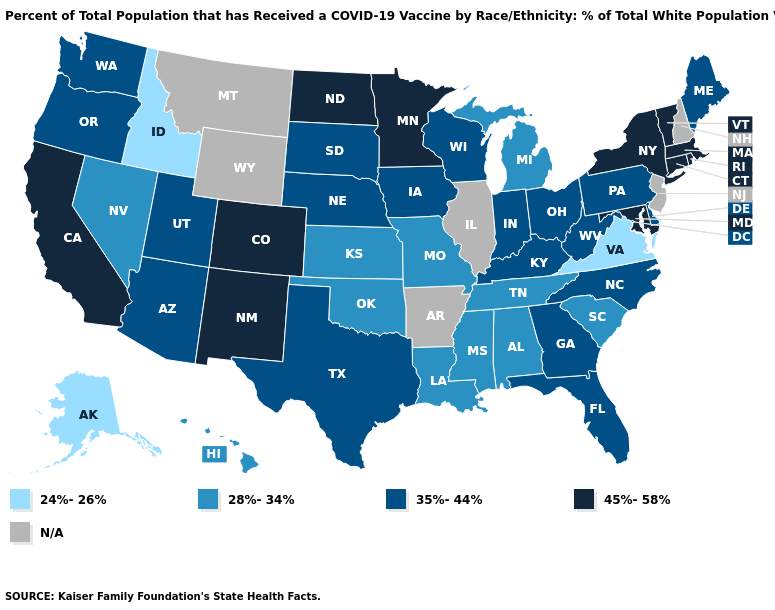What is the lowest value in the USA?
Short answer required. 24%-26%. What is the value of New Hampshire?
Be succinct. N/A. Does Alaska have the lowest value in the USA?
Keep it brief. Yes. What is the value of Hawaii?
Answer briefly. 28%-34%. What is the lowest value in the Northeast?
Write a very short answer. 35%-44%. Which states have the lowest value in the USA?
Keep it brief. Alaska, Idaho, Virginia. What is the highest value in the USA?
Give a very brief answer. 45%-58%. What is the value of Oklahoma?
Answer briefly. 28%-34%. Name the states that have a value in the range 24%-26%?
Short answer required. Alaska, Idaho, Virginia. Which states have the lowest value in the USA?
Write a very short answer. Alaska, Idaho, Virginia. What is the highest value in the West ?
Short answer required. 45%-58%. What is the value of Georgia?
Answer briefly. 35%-44%. Which states have the lowest value in the USA?
Give a very brief answer. Alaska, Idaho, Virginia. What is the value of Nebraska?
Give a very brief answer. 35%-44%. 